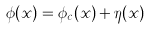Convert formula to latex. <formula><loc_0><loc_0><loc_500><loc_500>\phi ( x ) = \phi _ { c } ( x ) + \eta ( x )</formula> 